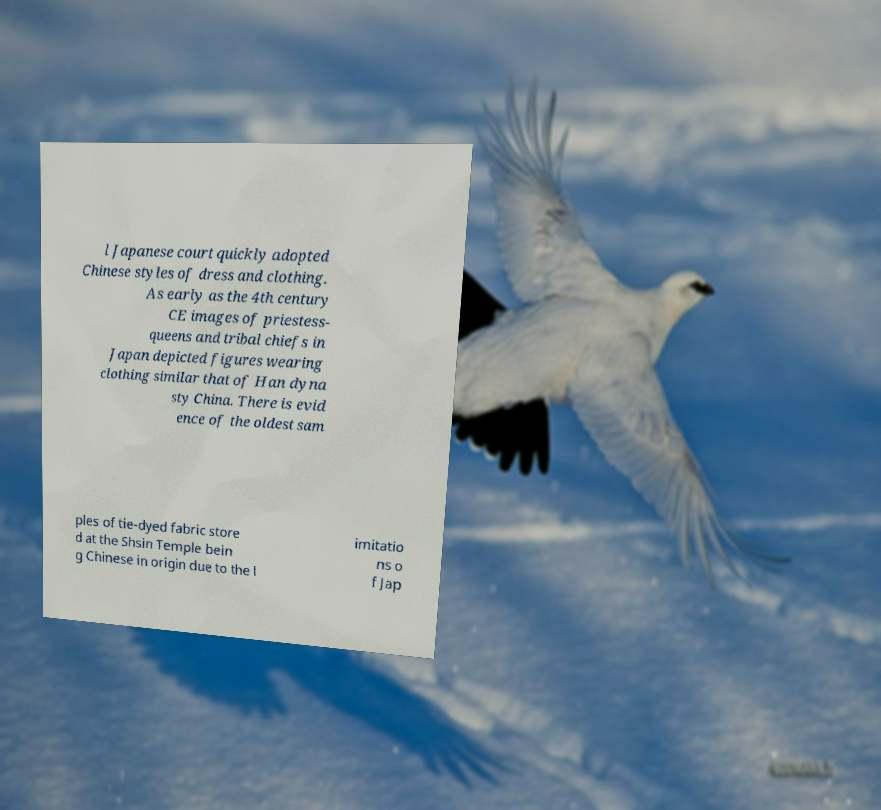There's text embedded in this image that I need extracted. Can you transcribe it verbatim? l Japanese court quickly adopted Chinese styles of dress and clothing. As early as the 4th century CE images of priestess- queens and tribal chiefs in Japan depicted figures wearing clothing similar that of Han dyna sty China. There is evid ence of the oldest sam ples of tie-dyed fabric store d at the Shsin Temple bein g Chinese in origin due to the l imitatio ns o f Jap 